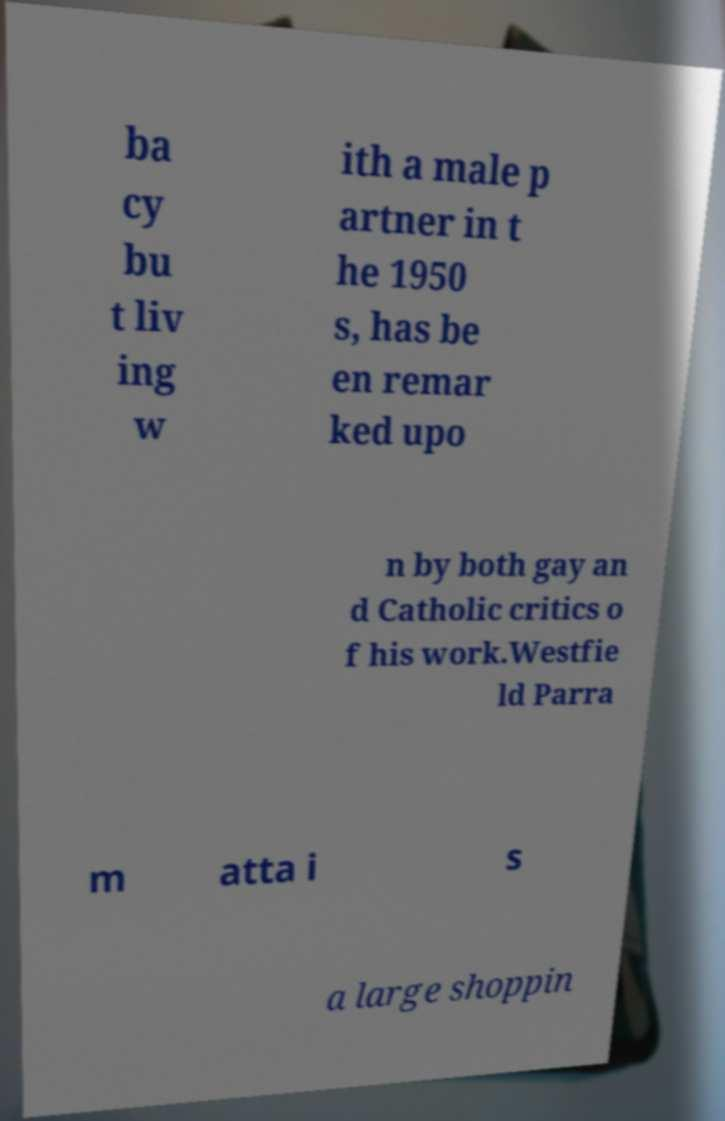Could you extract and type out the text from this image? ba cy bu t liv ing w ith a male p artner in t he 1950 s, has be en remar ked upo n by both gay an d Catholic critics o f his work.Westfie ld Parra m atta i s a large shoppin 